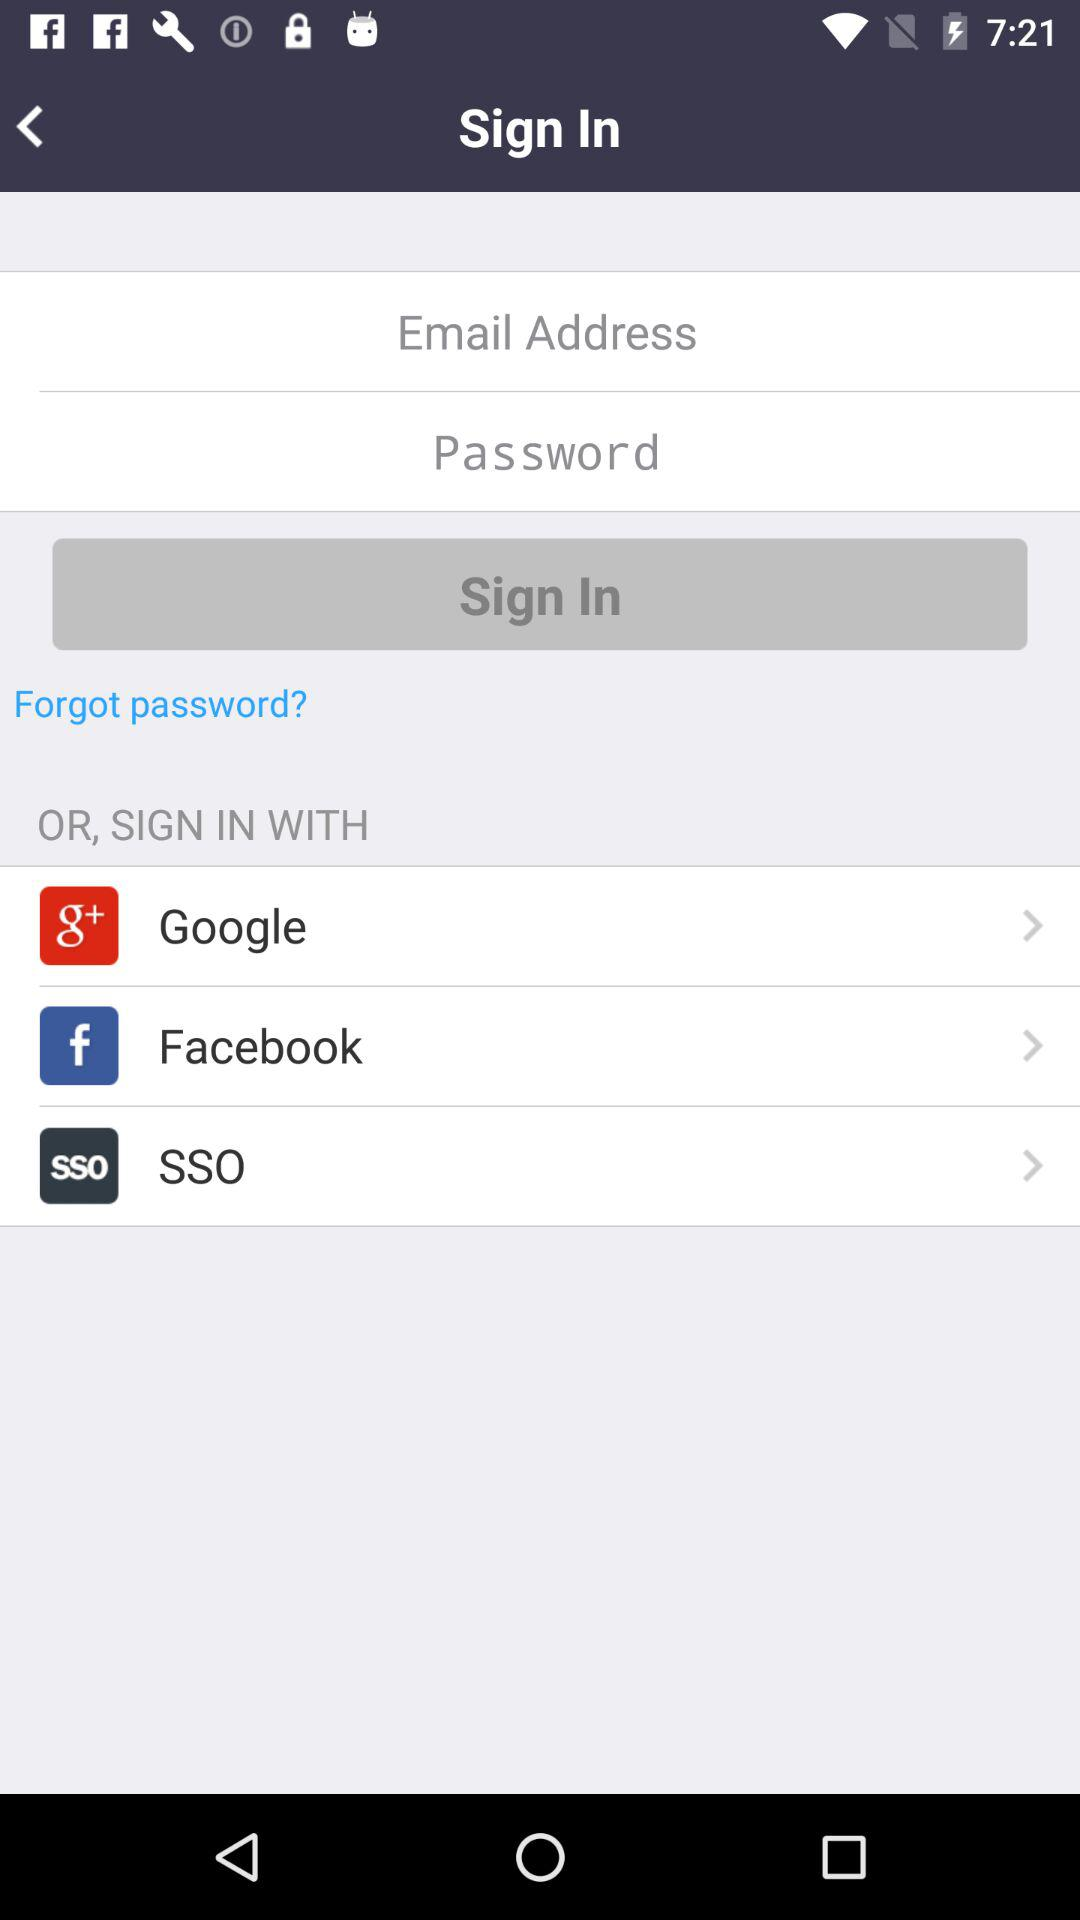What is the email address? The email address is appcrawler5@gmail.com. 